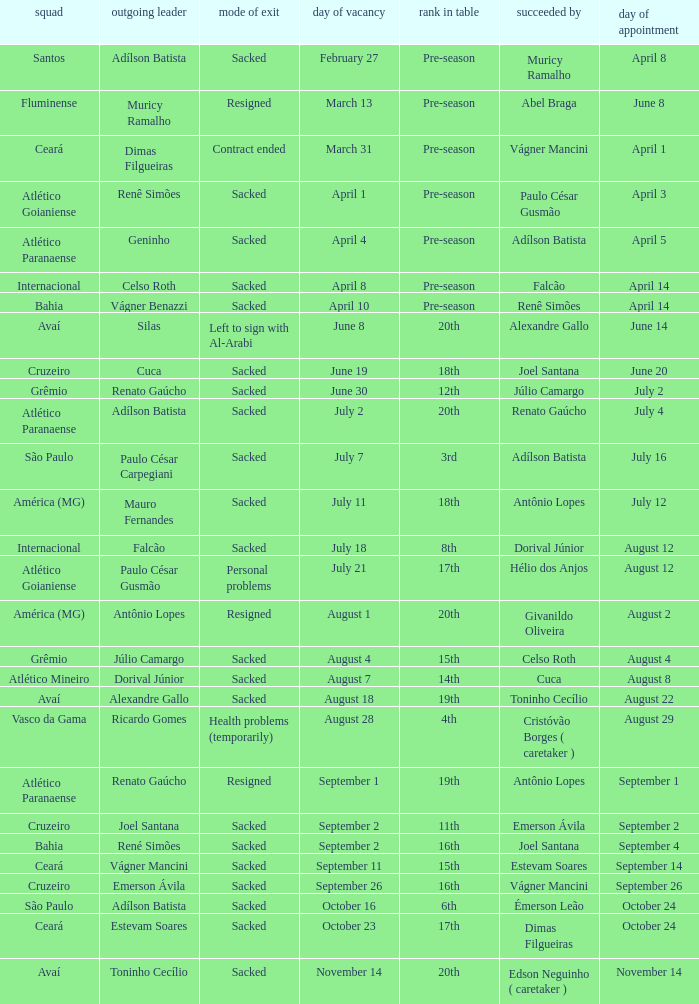How many times did Silas leave as a team manager? 1.0. 